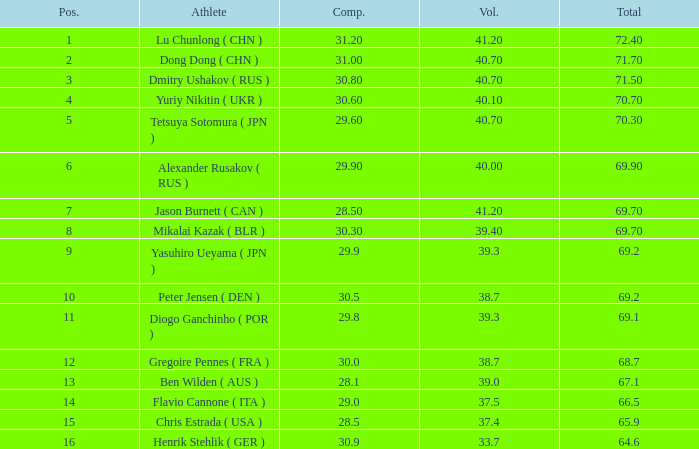What's the position that has a total less than 66.5m, a compulsory of 30.9 and voluntary less than 33.7? None. 